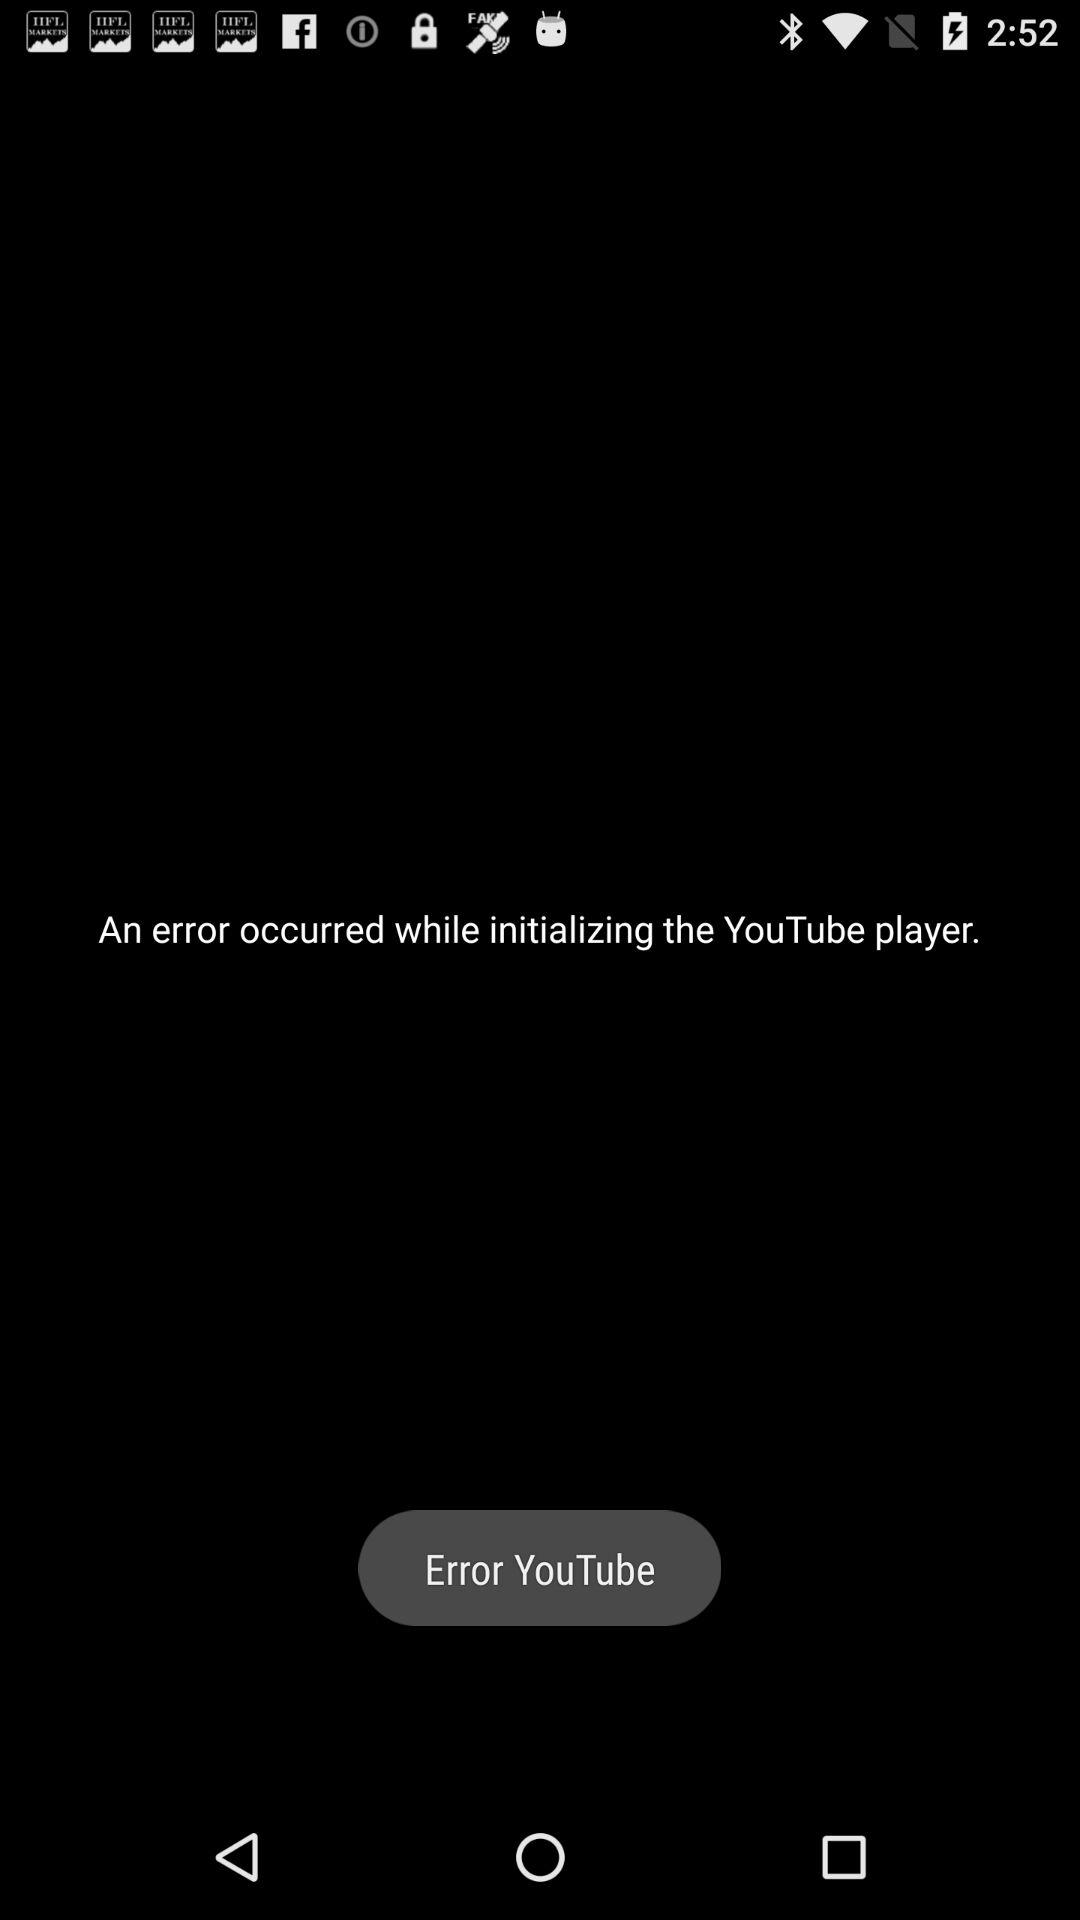What app observed an error while initializing? An error was observed while initializing the "YouTube player". 